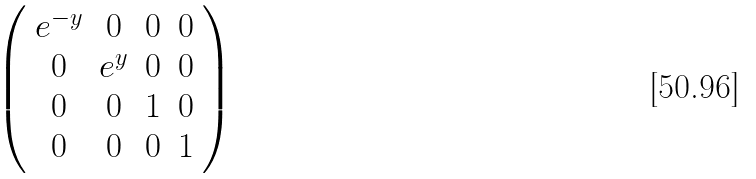<formula> <loc_0><loc_0><loc_500><loc_500>\left ( \begin{array} { c c c c } e ^ { - y } & 0 & 0 & 0 \\ 0 & e ^ { y } & 0 & 0 \\ 0 & 0 & 1 & 0 \\ 0 & 0 & 0 & 1 \end{array} \right )</formula> 